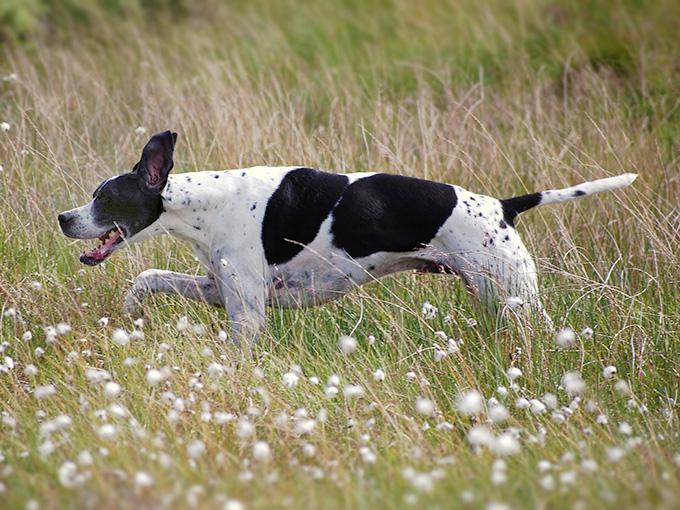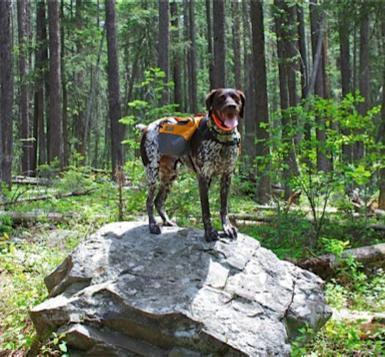The first image is the image on the left, the second image is the image on the right. Given the left and right images, does the statement "There is the same number of dogs in both images." hold true? Answer yes or no. Yes. The first image is the image on the left, the second image is the image on the right. Examine the images to the left and right. Is the description "Each image includes one hound in a standing position, and the dog on the left is black-and-white with an open mouth and tail sticking out." accurate? Answer yes or no. Yes. 